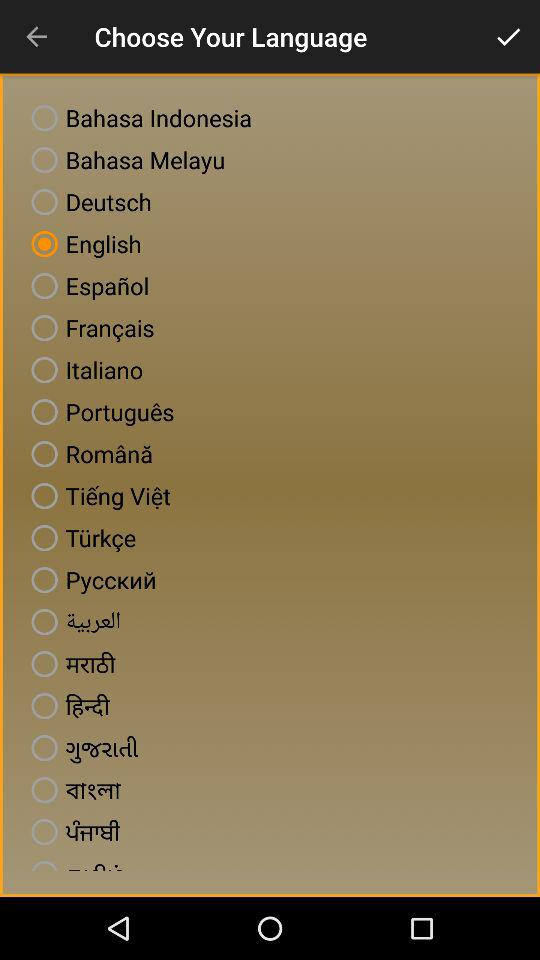Which language is selected? The selected language is English. 